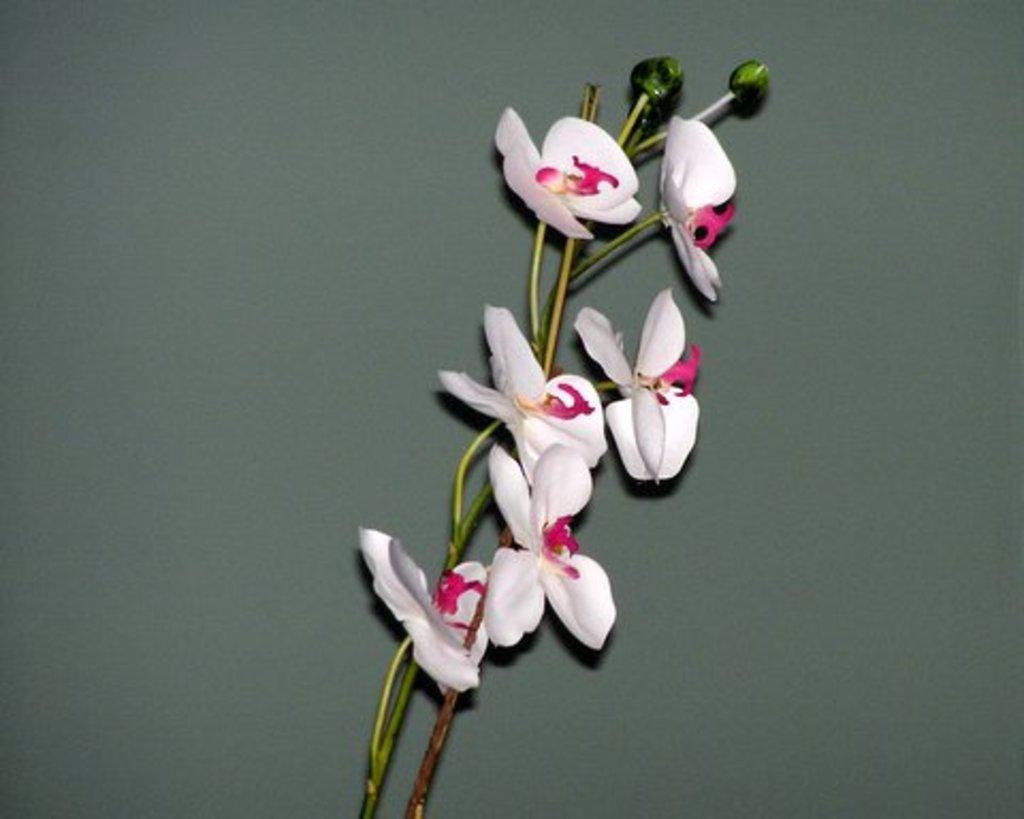How would you summarize this image in a sentence or two? In this image there are white flowers on the surface. 